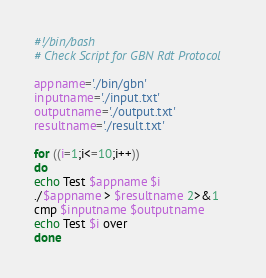Convert code to text. <code><loc_0><loc_0><loc_500><loc_500><_Bash_>#!/bin/bash
# Check Script for GBN Rdt Protocol

appname='./bin/gbn'
inputname='./input.txt'
outputname='./output.txt'
resultname='./result.txt'

for ((i=1;i<=10;i++))
do
echo Test $appname $i
./$appname > $resultname 2>&1
cmp $inputname $outputname
echo Test $i over
done
</code> 